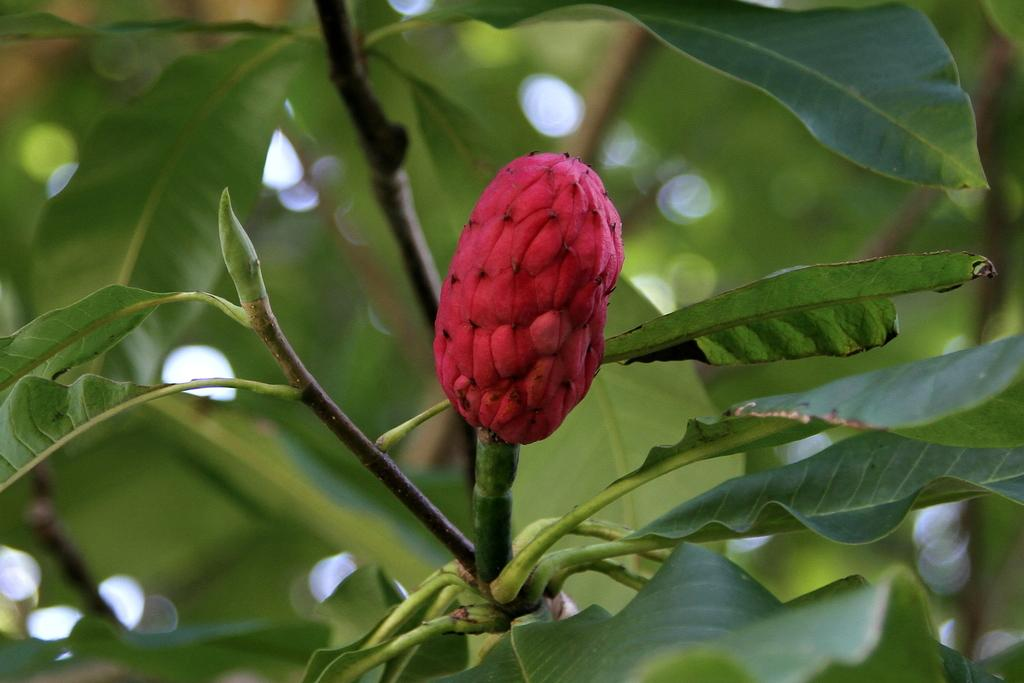What is the main subject of the image? The main subject of the image is a stem with leaves and a bud. Can you describe the arrangement of the leaves and bud in the image? There are leaves behind the bud in the image. What color is predominant in the background of the image? The background of the image is green and blurred. How much profit can be made from the button in the image? There is no button present in the image, so it is not possible to determine any potential profit. 